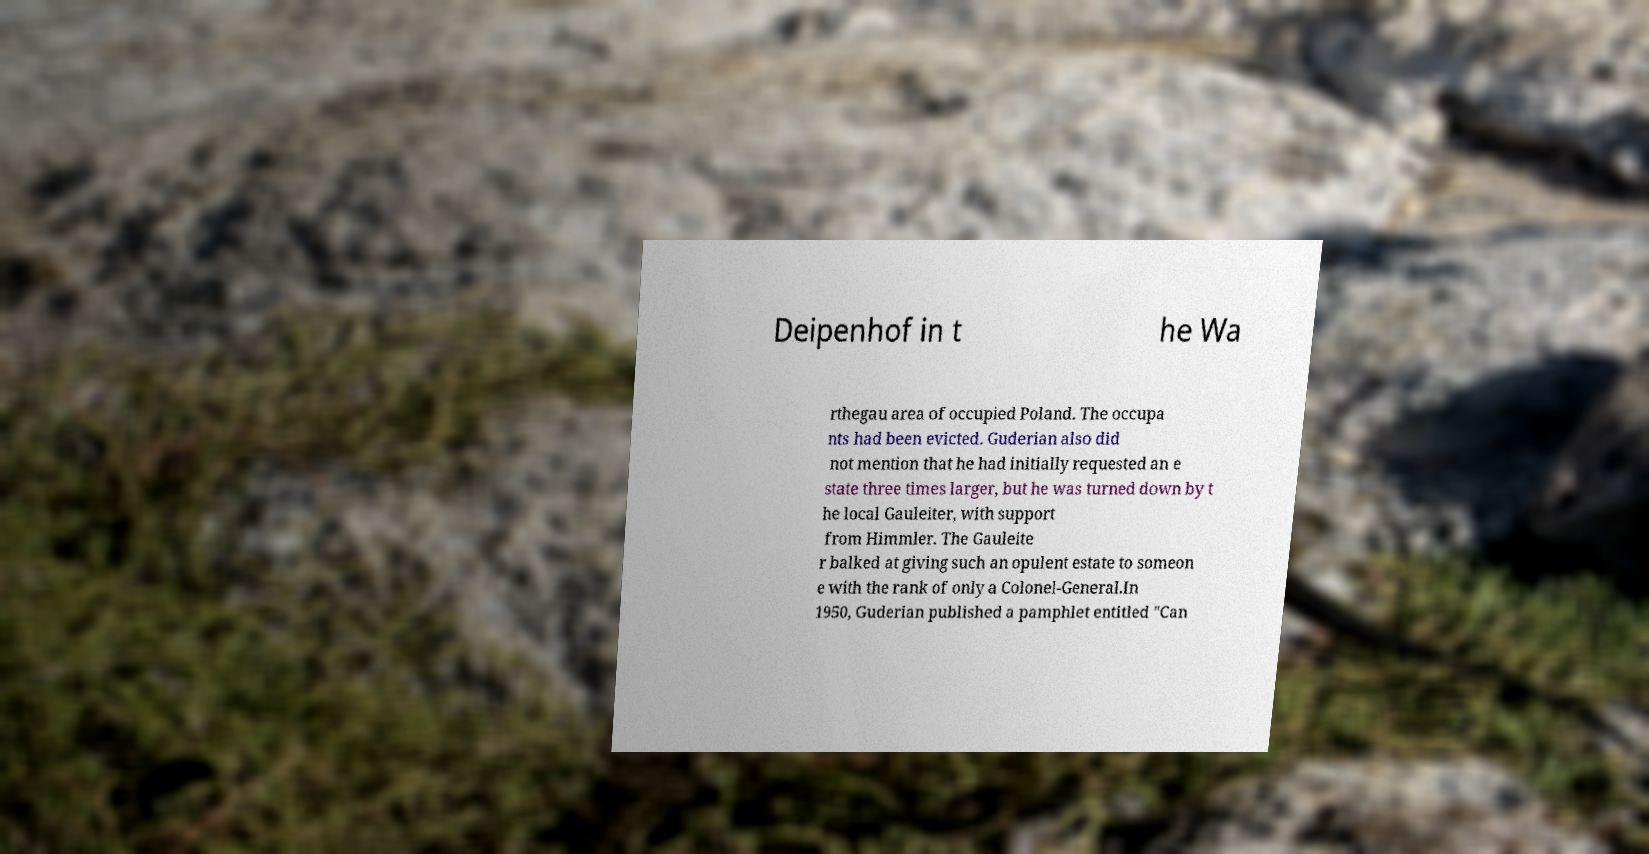Could you assist in decoding the text presented in this image and type it out clearly? Deipenhof in t he Wa rthegau area of occupied Poland. The occupa nts had been evicted. Guderian also did not mention that he had initially requested an e state three times larger, but he was turned down by t he local Gauleiter, with support from Himmler. The Gauleite r balked at giving such an opulent estate to someon e with the rank of only a Colonel-General.In 1950, Guderian published a pamphlet entitled "Can 